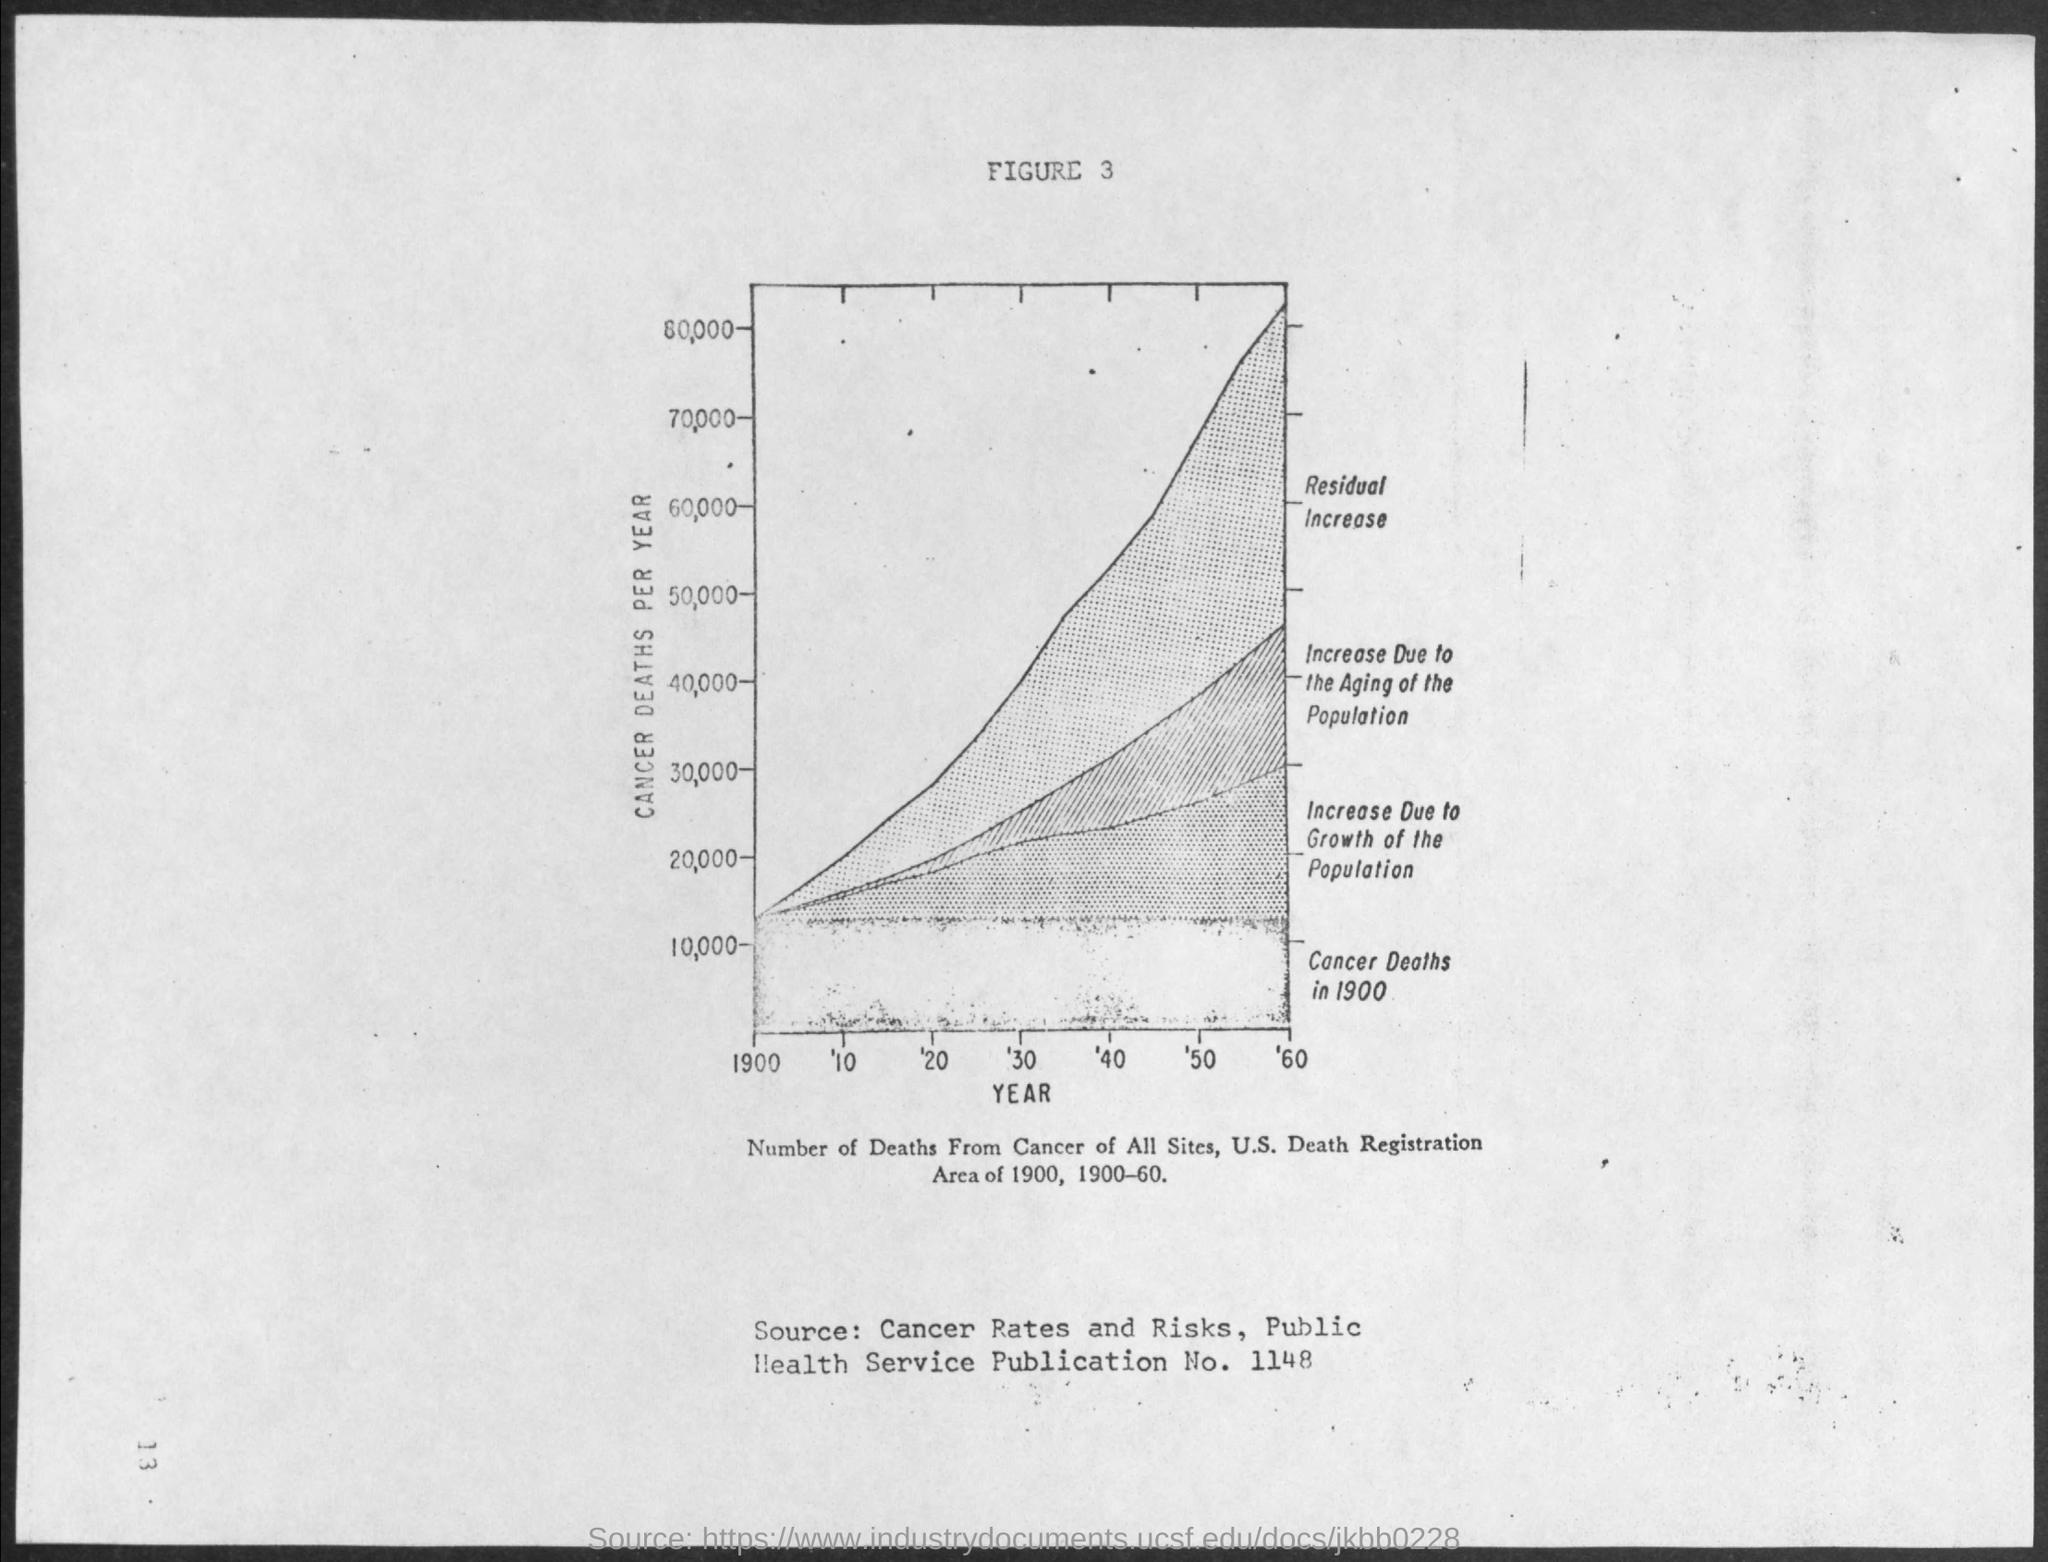Point out several critical features in this image. The x-axis displays the year, which is plotted in the chart. In the y-axis, the number of cancer deaths per year is plotted. 